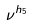<formula> <loc_0><loc_0><loc_500><loc_500>\nu ^ { h _ { 5 } }</formula> 